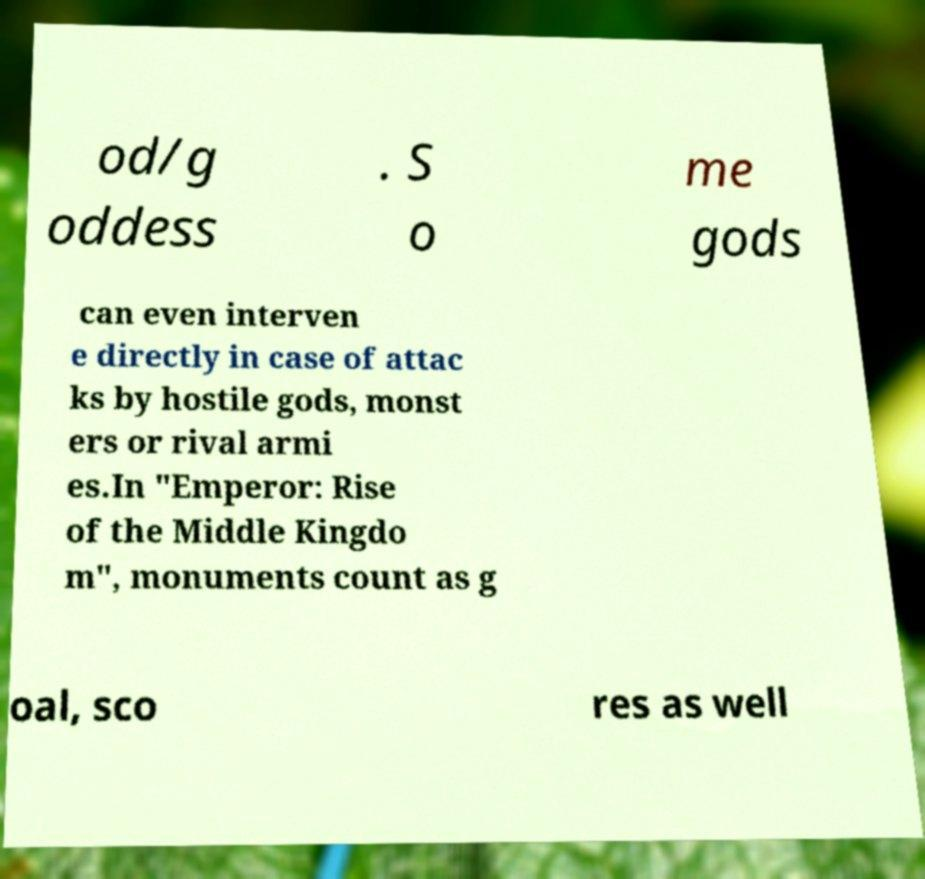Could you assist in decoding the text presented in this image and type it out clearly? od/g oddess . S o me gods can even interven e directly in case of attac ks by hostile gods, monst ers or rival armi es.In "Emperor: Rise of the Middle Kingdo m", monuments count as g oal, sco res as well 